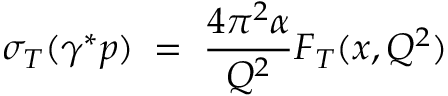<formula> <loc_0><loc_0><loc_500><loc_500>\sigma _ { T } ( \gamma ^ { * } p ) \, = \, \frac { 4 \pi ^ { 2 } \alpha } { Q ^ { 2 } } F _ { T } ( x , Q ^ { 2 } )</formula> 